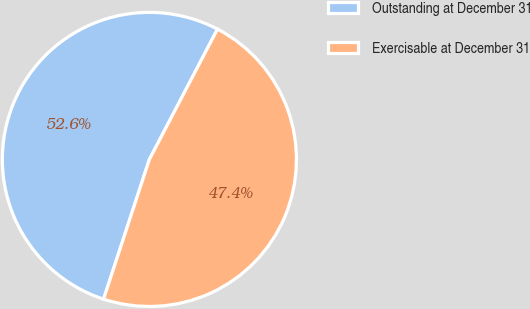Convert chart to OTSL. <chart><loc_0><loc_0><loc_500><loc_500><pie_chart><fcel>Outstanding at December 31<fcel>Exercisable at December 31<nl><fcel>52.62%<fcel>47.38%<nl></chart> 